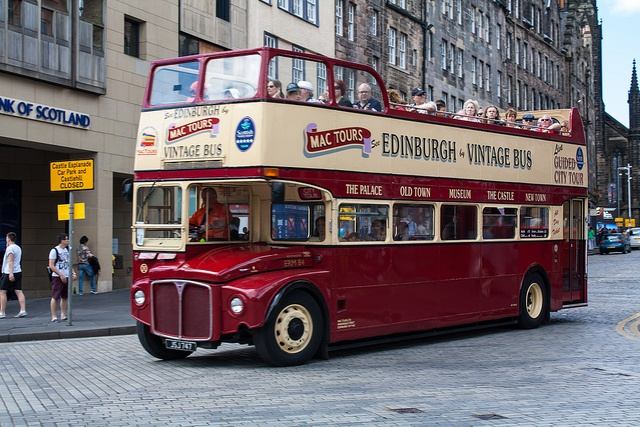Describe the objects in this image and their specific colors. I can see bus in gray, maroon, black, tan, and lightgray tones, people in gray, black, maroon, and darkgray tones, people in gray, black, and darkgray tones, people in gray, black, maroon, and brown tones, and people in gray, black, darkgray, and lavender tones in this image. 